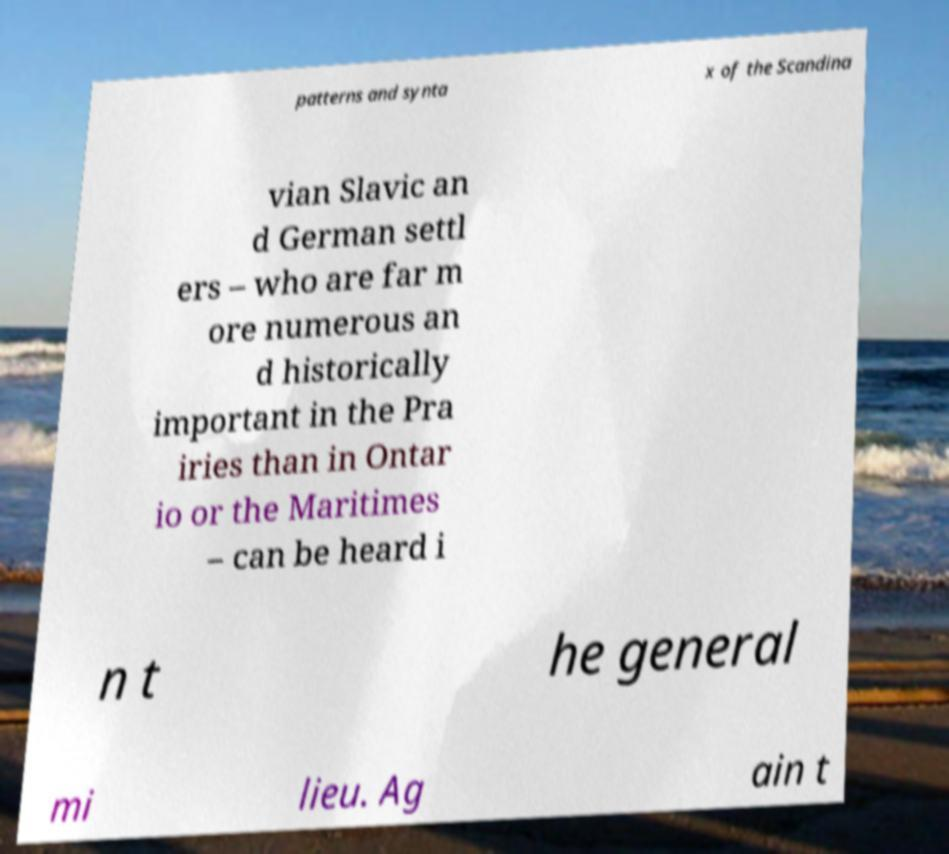Could you extract and type out the text from this image? patterns and synta x of the Scandina vian Slavic an d German settl ers – who are far m ore numerous an d historically important in the Pra iries than in Ontar io or the Maritimes – can be heard i n t he general mi lieu. Ag ain t 